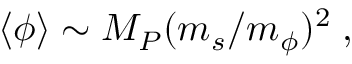<formula> <loc_0><loc_0><loc_500><loc_500>\langle \phi \rangle \sim M _ { P } ( m _ { s } / m _ { \phi } ) ^ { 2 } \, ,</formula> 